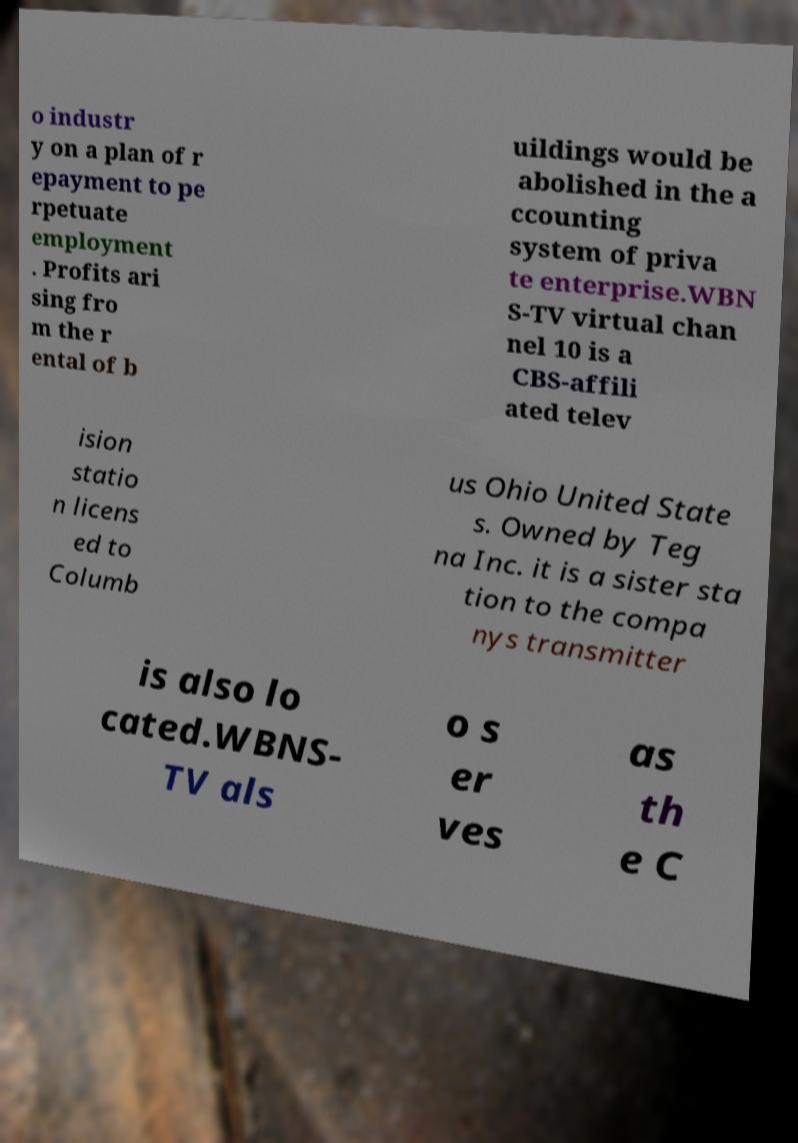Please identify and transcribe the text found in this image. o industr y on a plan of r epayment to pe rpetuate employment . Profits ari sing fro m the r ental of b uildings would be abolished in the a ccounting system of priva te enterprise.WBN S-TV virtual chan nel 10 is a CBS-affili ated telev ision statio n licens ed to Columb us Ohio United State s. Owned by Teg na Inc. it is a sister sta tion to the compa nys transmitter is also lo cated.WBNS- TV als o s er ves as th e C 